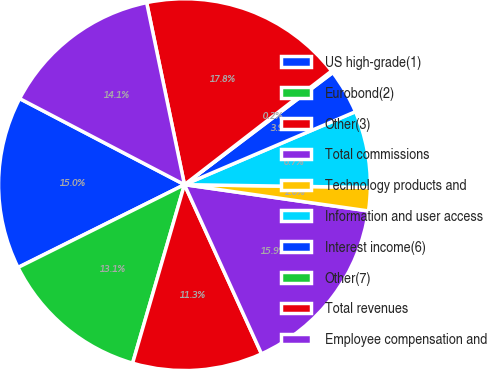<chart> <loc_0><loc_0><loc_500><loc_500><pie_chart><fcel>US high-grade(1)<fcel>Eurobond(2)<fcel>Other(3)<fcel>Total commissions<fcel>Technology products and<fcel>Information and user access<fcel>Interest income(6)<fcel>Other(7)<fcel>Total revenues<fcel>Employee compensation and<nl><fcel>15.01%<fcel>13.15%<fcel>11.3%<fcel>15.94%<fcel>2.02%<fcel>6.66%<fcel>3.88%<fcel>0.17%<fcel>17.79%<fcel>14.08%<nl></chart> 